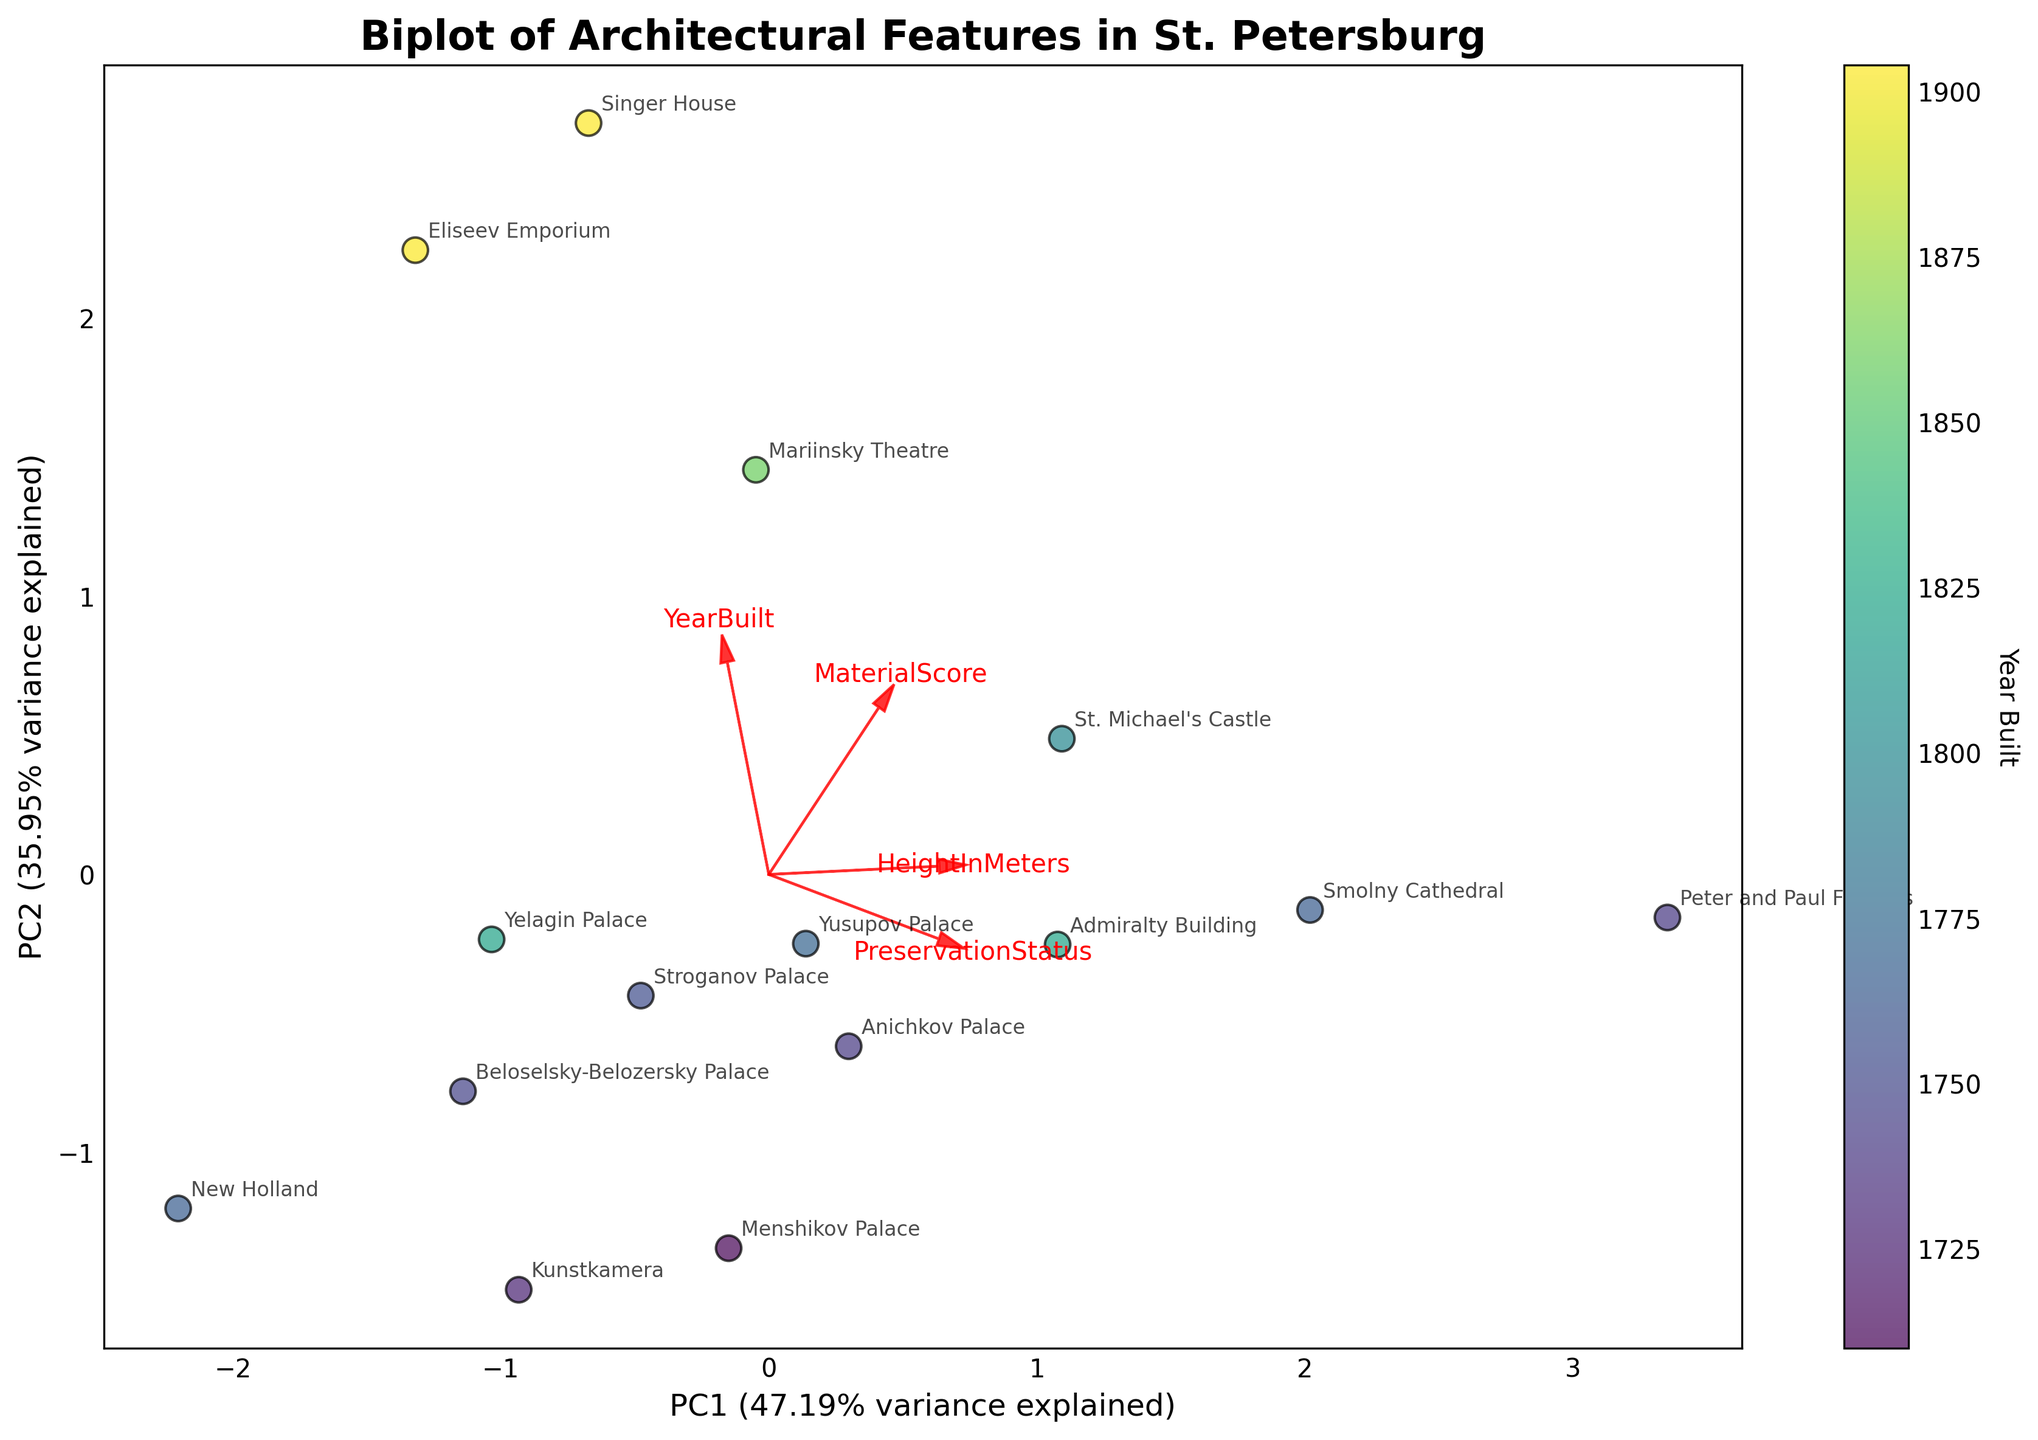What is the title of the biplot? The title of the plot is typically found at the top of the figure. It should describe the content or purpose of the figure succinctly.
Answer: "Biplot of Architectural Features in St. Petersburg" How many buildings are represented in the biplot? Count the number of data points in the scatter plot, each representing a building. The annotations can help identify the total number of buildings.
Answer: 15 Which building has the highest preservation status? Look for the building with the highest coordinate along the vector representing 'PreservationStatus'. The annotations will help identify the specific building.
Answer: Peter and Paul Fortress What is the color used for buildings built in the 1800s? Refer to the color scale (colorbar) which maps the 'Year Built' to colors. Identify the range corresponding to the 1800s and its associated color.
Answer: Yellow to light green Which feature has the largest contribution to PC1? Examine the direction and length of the arrows (feature vectors). The feature with the arrow pointing furthest along the PC1 axis has the highest contribution.
Answer: YearBuilt Compare the height in meters between the Mariinsky Theatre and the Singer House. Which is taller? Locate the positions of 'Mariinsky Theatre' and 'Singer House' on the biplot. Examine their coordinates along the 'HeightInMeters' vector to compare their heights.
Answer: Singer House Between 'Baroque' and 'Art Nouveau' architectural styles, which has more buildings with higher preservation status? Identify the buildings with 'Baroque' and 'Art Nouveau' styles from the annotations, then compare their positions along the 'PreservationStatus' vector.
Answer: Baroque Which building has the most extreme value along PC2? Look for the building that is furthest from the origin along the PC2 axis in either direction. The annotation will identify the building.
Answer: Smolny Cathedral Is there a noticeable trend between the 'Year Built' and 'Preservation Status'? Provide an explanation for your observation. Check the direction and alignment of the 'Year Built' and 'Preservation Status' vectors. If they are closely aligned, there is a direct relationship; otherwise, the relationship is weak or inverse.
Answer: Yes, a slight positive relationship Which architectural feature contributes least to PC2? Examine the lengths of the arrows (feature vectors). The feature with the shortest arrow along the PC2 axis has the smallest contribution.
Answer: YearBuilt 